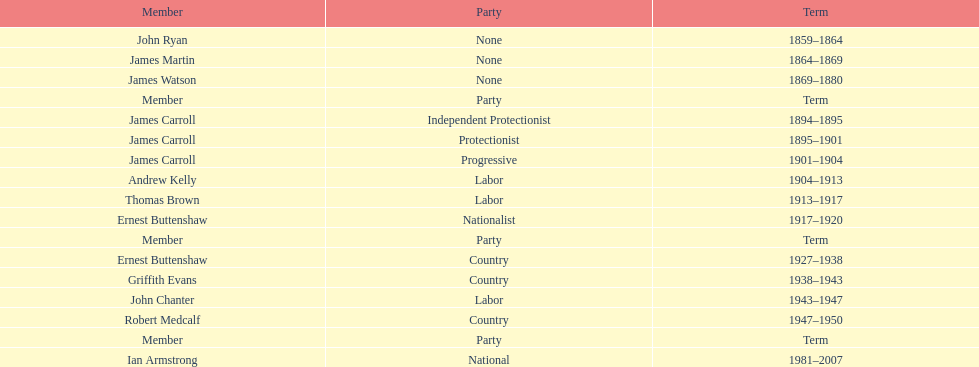Which member of the second incarnation of the lachlan was also a nationalist? Ernest Buttenshaw. Would you be able to parse every entry in this table? {'header': ['Member', 'Party', 'Term'], 'rows': [['John Ryan', 'None', '1859–1864'], ['James Martin', 'None', '1864–1869'], ['James Watson', 'None', '1869–1880'], ['Member', 'Party', 'Term'], ['James Carroll', 'Independent Protectionist', '1894–1895'], ['James Carroll', 'Protectionist', '1895–1901'], ['James Carroll', 'Progressive', '1901–1904'], ['Andrew Kelly', 'Labor', '1904–1913'], ['Thomas Brown', 'Labor', '1913–1917'], ['Ernest Buttenshaw', 'Nationalist', '1917–1920'], ['Member', 'Party', 'Term'], ['Ernest Buttenshaw', 'Country', '1927–1938'], ['Griffith Evans', 'Country', '1938–1943'], ['John Chanter', 'Labor', '1943–1947'], ['Robert Medcalf', 'Country', '1947–1950'], ['Member', 'Party', 'Term'], ['Ian Armstrong', 'National', '1981–2007']]} 